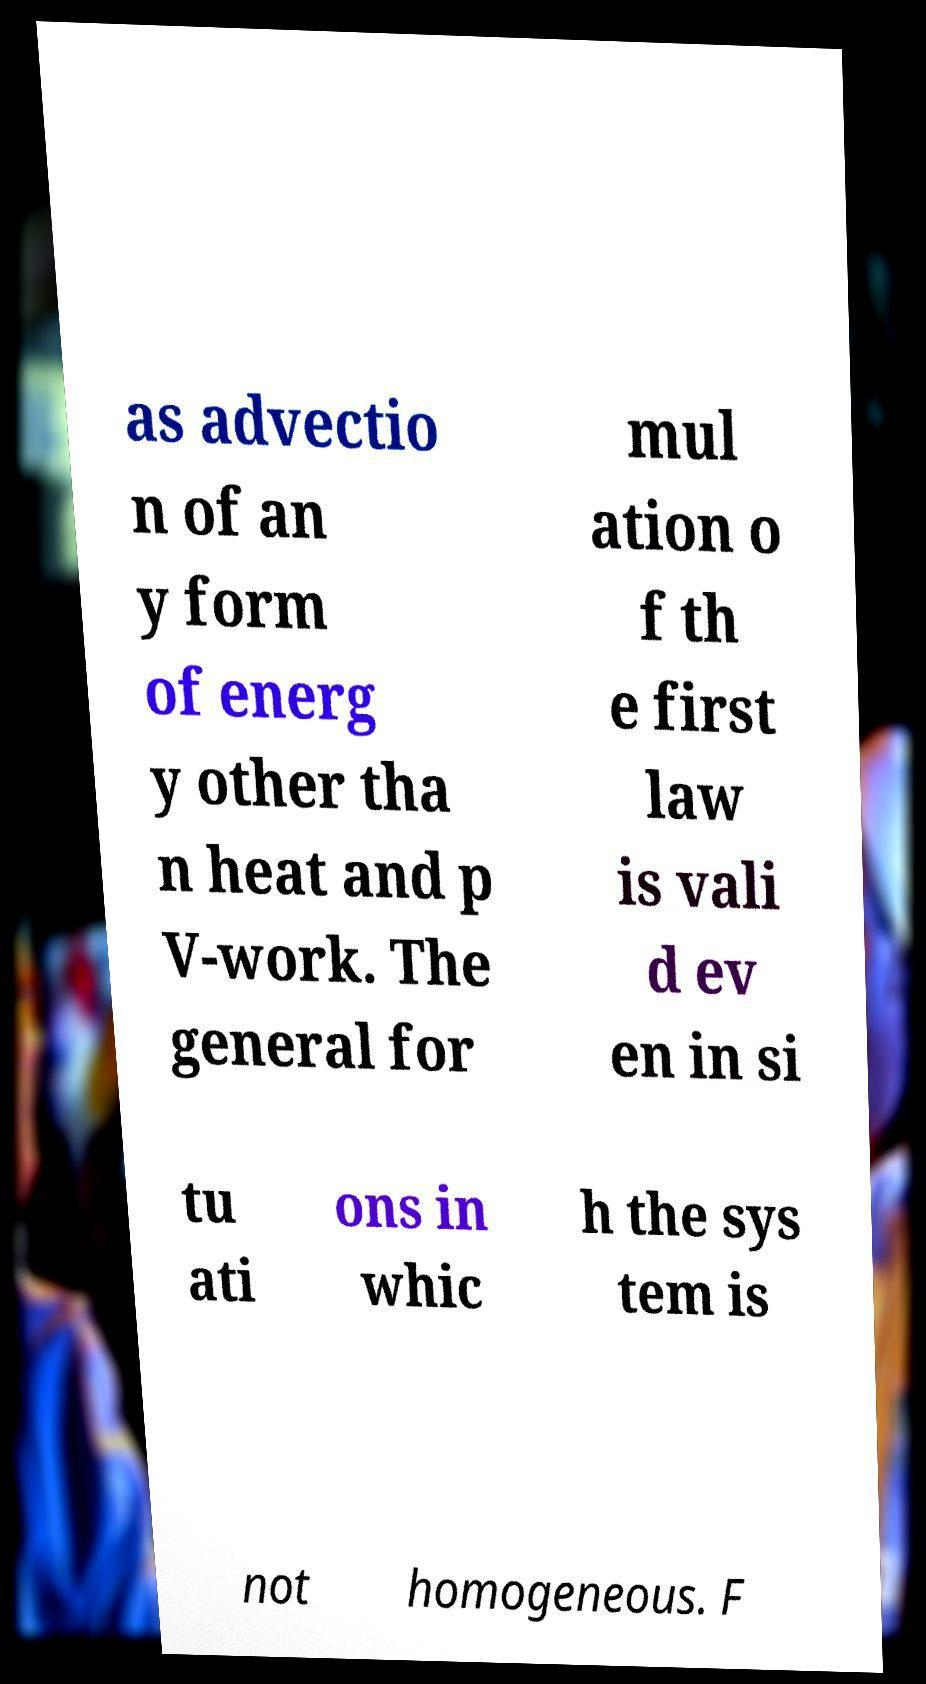Can you accurately transcribe the text from the provided image for me? as advectio n of an y form of energ y other tha n heat and p V-work. The general for mul ation o f th e first law is vali d ev en in si tu ati ons in whic h the sys tem is not homogeneous. F 